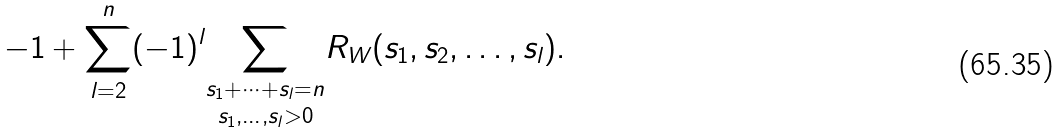<formula> <loc_0><loc_0><loc_500><loc_500>- 1 + \sum _ { l = 2 } ^ { n } ( - 1 ) ^ { l } \underset { s _ { 1 } , \dots , s _ { l } > 0 } { \sum _ { s _ { 1 } + \dots + s _ { l } = n } } R _ { W } ( s _ { 1 } , s _ { 2 } , \dots , s _ { l } ) .</formula> 